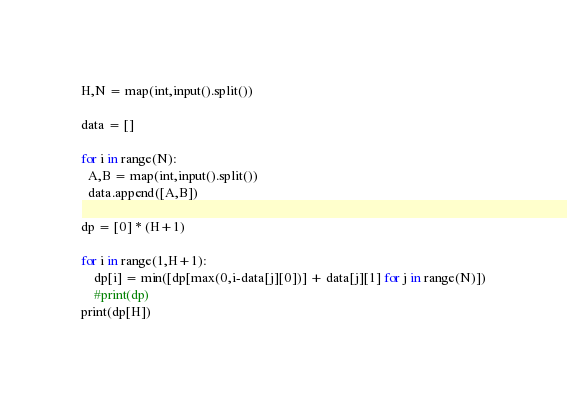<code> <loc_0><loc_0><loc_500><loc_500><_Python_>H,N = map(int,input().split())

data = []

for i in range(N):
  A,B = map(int,input().split())
  data.append([A,B])

dp = [0] * (H+1)

for i in range(1,H+1):
    dp[i] = min([dp[max(0,i-data[j][0])] + data[j][1] for j in range(N)])
    #print(dp)
print(dp[H])</code> 